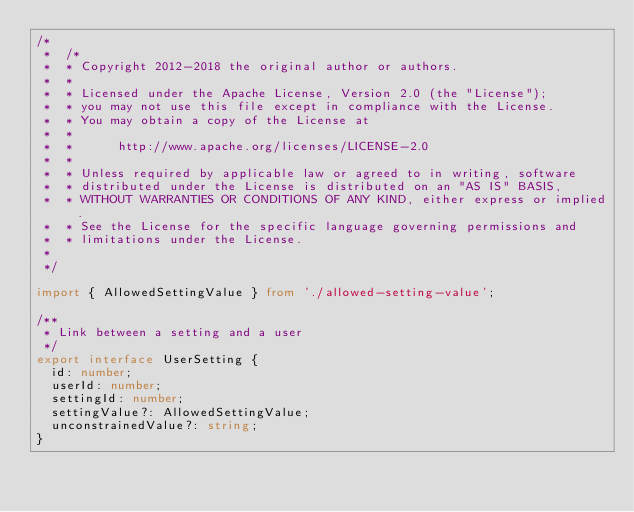<code> <loc_0><loc_0><loc_500><loc_500><_TypeScript_>/*
 *  /*
 *  * Copyright 2012-2018 the original author or authors.
 *  *
 *  * Licensed under the Apache License, Version 2.0 (the "License");
 *  * you may not use this file except in compliance with the License.
 *  * You may obtain a copy of the License at
 *  *
 *  *      http://www.apache.org/licenses/LICENSE-2.0
 *  *
 *  * Unless required by applicable law or agreed to in writing, software
 *  * distributed under the License is distributed on an "AS IS" BASIS,
 *  * WITHOUT WARRANTIES OR CONDITIONS OF ANY KIND, either express or implied.
 *  * See the License for the specific language governing permissions and
 *  * limitations under the License.
 *
 */

import { AllowedSettingValue } from './allowed-setting-value';

/**
 * Link between a setting and a user
 */
export interface UserSetting {
  id: number;
  userId: number;
  settingId: number;
  settingValue?: AllowedSettingValue;
  unconstrainedValue?: string;
}
</code> 